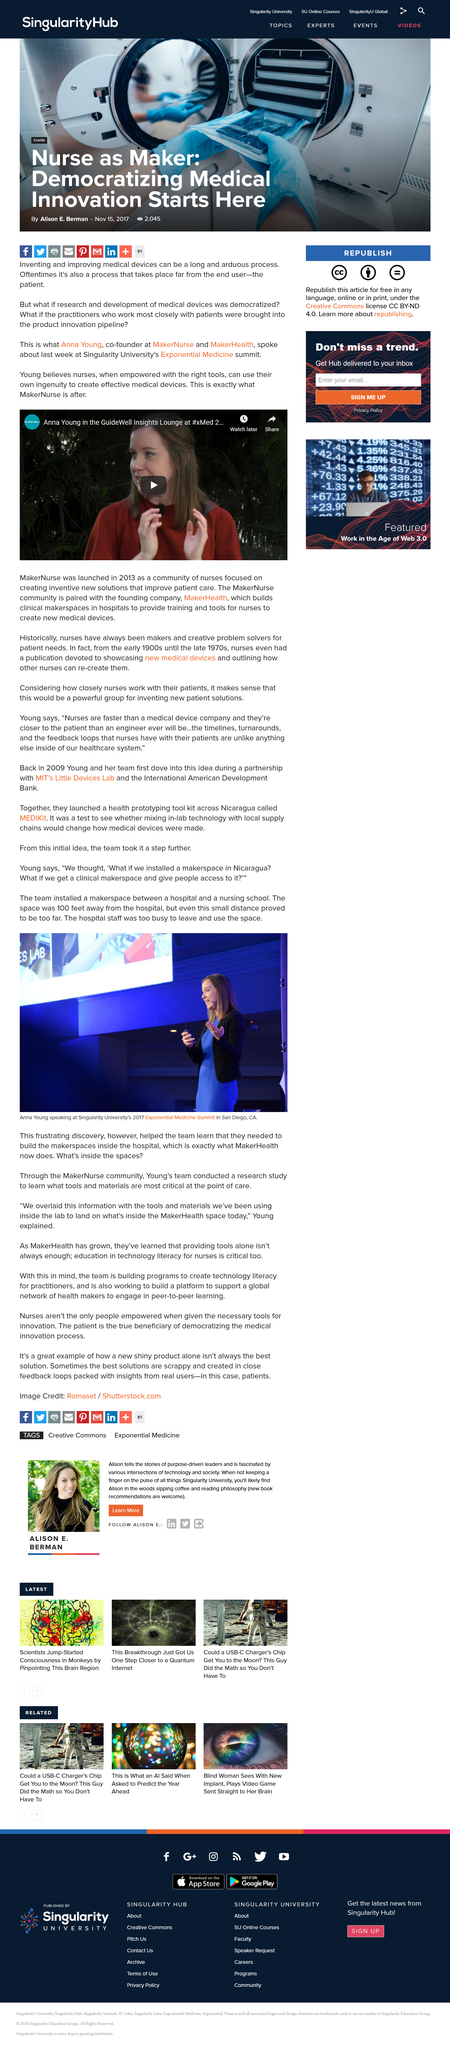Identify some key points in this picture. The image depicts Anna Young. The article titled "Nurse as Maker: Democratizing Medical Innovation Starts Here" was written by Alison E. Berman. Anna Young is the co-founder of MakerNurse and MakerHealth. The makerspace was located 100 feet away from the hospital, providing convenient access for patients and staff. Inventing and improving medical devices is a long and arduous process that requires significant time and effort. 